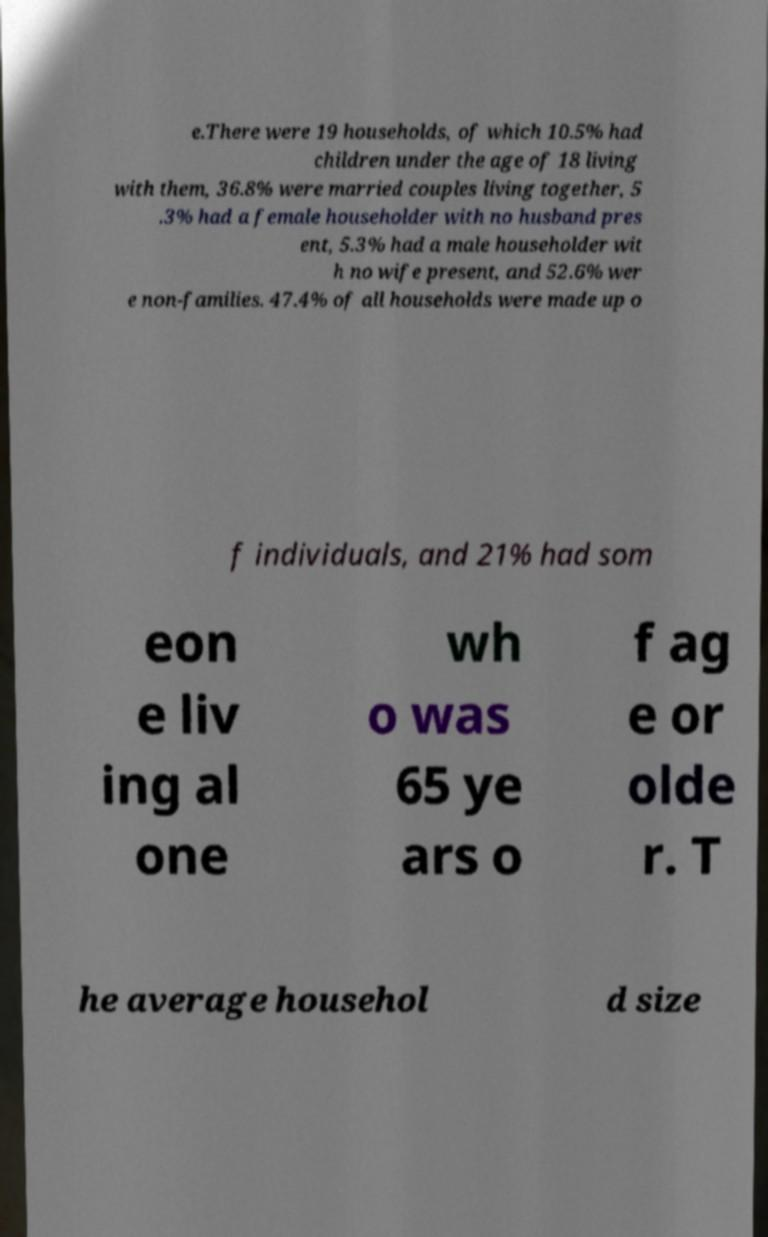I need the written content from this picture converted into text. Can you do that? e.There were 19 households, of which 10.5% had children under the age of 18 living with them, 36.8% were married couples living together, 5 .3% had a female householder with no husband pres ent, 5.3% had a male householder wit h no wife present, and 52.6% wer e non-families. 47.4% of all households were made up o f individuals, and 21% had som eon e liv ing al one wh o was 65 ye ars o f ag e or olde r. T he average househol d size 